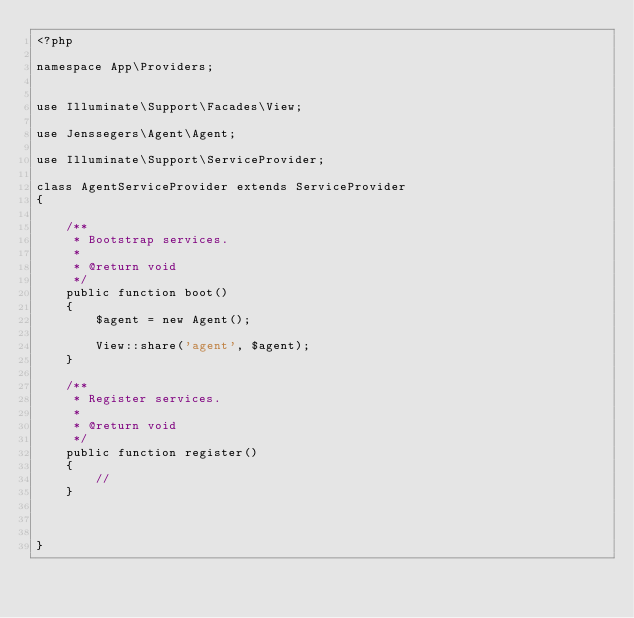<code> <loc_0><loc_0><loc_500><loc_500><_PHP_><?php

namespace App\Providers;


use Illuminate\Support\Facades\View;

use Jenssegers\Agent\Agent;

use Illuminate\Support\ServiceProvider;

class AgentServiceProvider extends ServiceProvider
{

    /**
     * Bootstrap services.
     *
     * @return void
     */
    public function boot()
    {
        $agent = new Agent();

        View::share('agent', $agent);
    }

    /**
     * Register services.
     *
     * @return void
     */
    public function register()
    {
        //
    }


    
}
</code> 